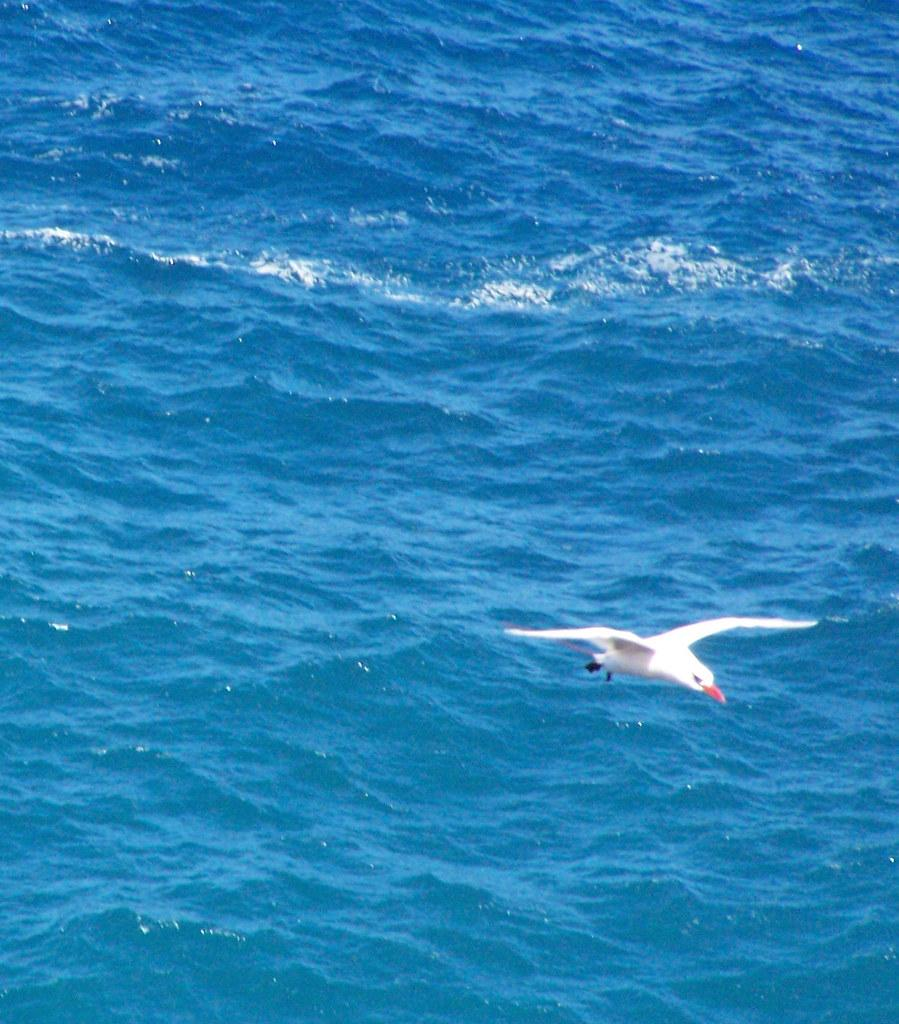What type of animal can be seen in the image? There is a bird in the image. What can be seen in the background of the image? There is water visible in the background of the image. What type of chalk is the bird using to draw in the image? There is no chalk present in the image, and the bird is not drawing. 